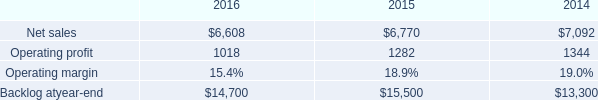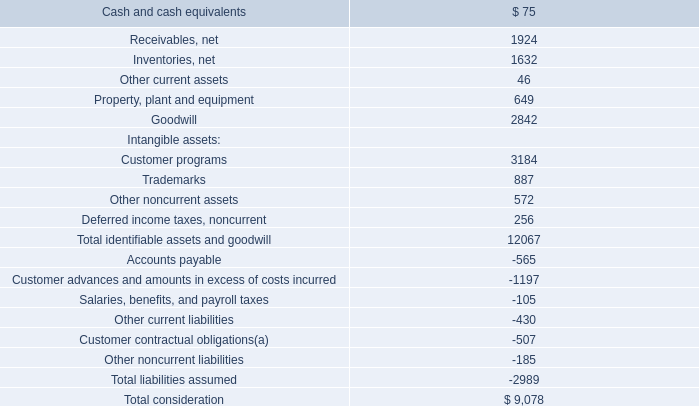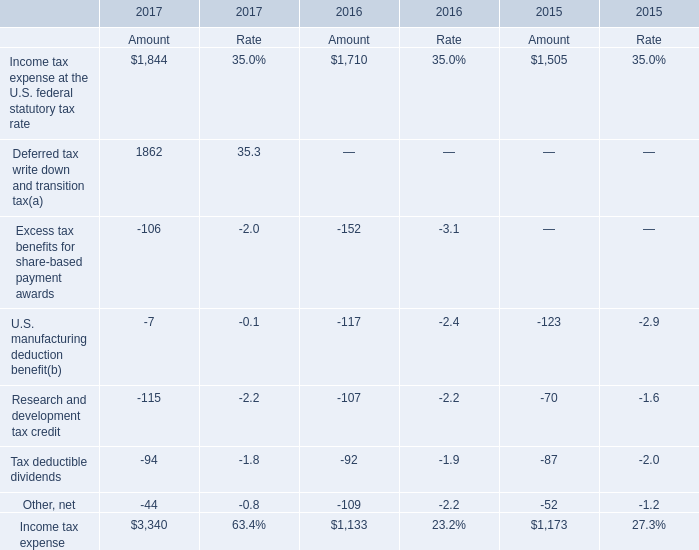What is the total amount of Net sales of 2014, and Deferred tax write down and transition tax of 2017 Amount ? 
Computations: (7092.0 + 1862.0)
Answer: 8954.0. 